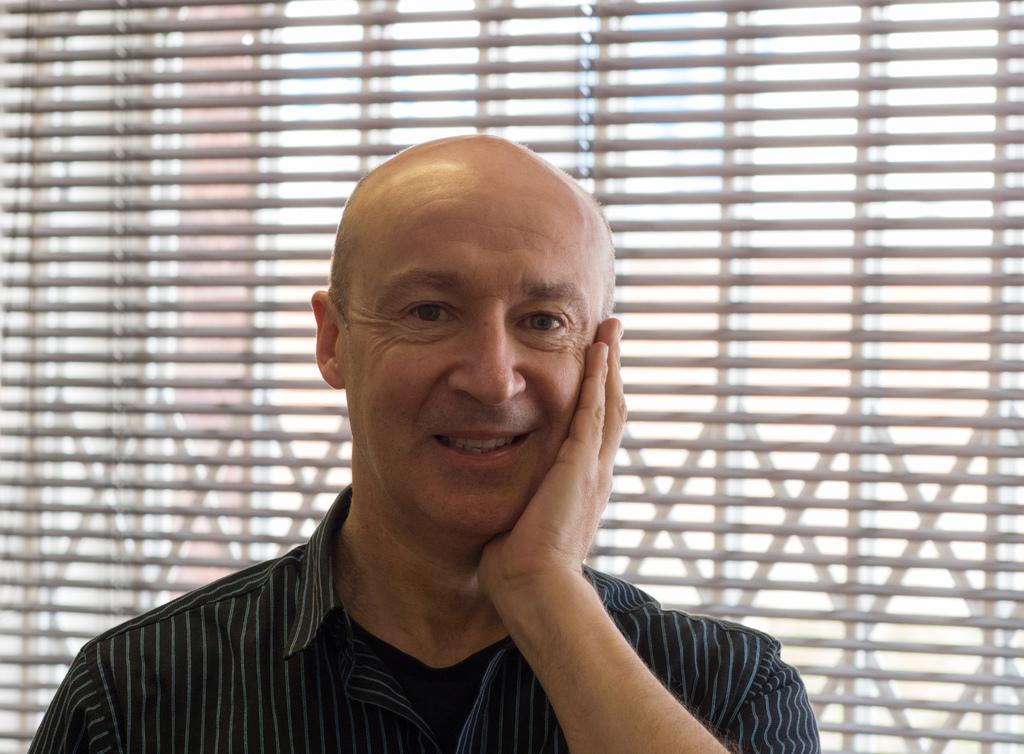What is present in the picture? There is a person in the picture. How is the person's expression in the image? The person is smiling. What type of drug can be seen in the person's hand in the image? There is no drug present in the image; the person is simply smiling. 